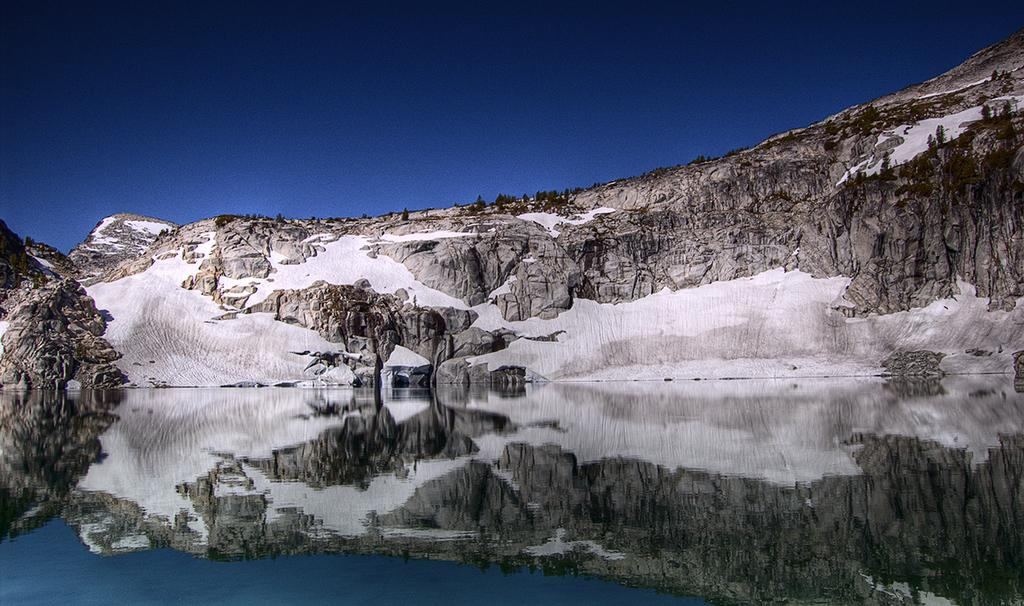What body of water is visible in the image? There is a lake in the image. Where is the lake located in relation to the other elements in the image? The lake is in the front of the image. What is located behind the lake? There is a hill behind the lake. What is the condition of the hill in the image? The hill is covered with snow. What is visible above the hill in the image? The sky is visible above the hill. What type of pollution can be seen in the image? There is no pollution visible in the image. 